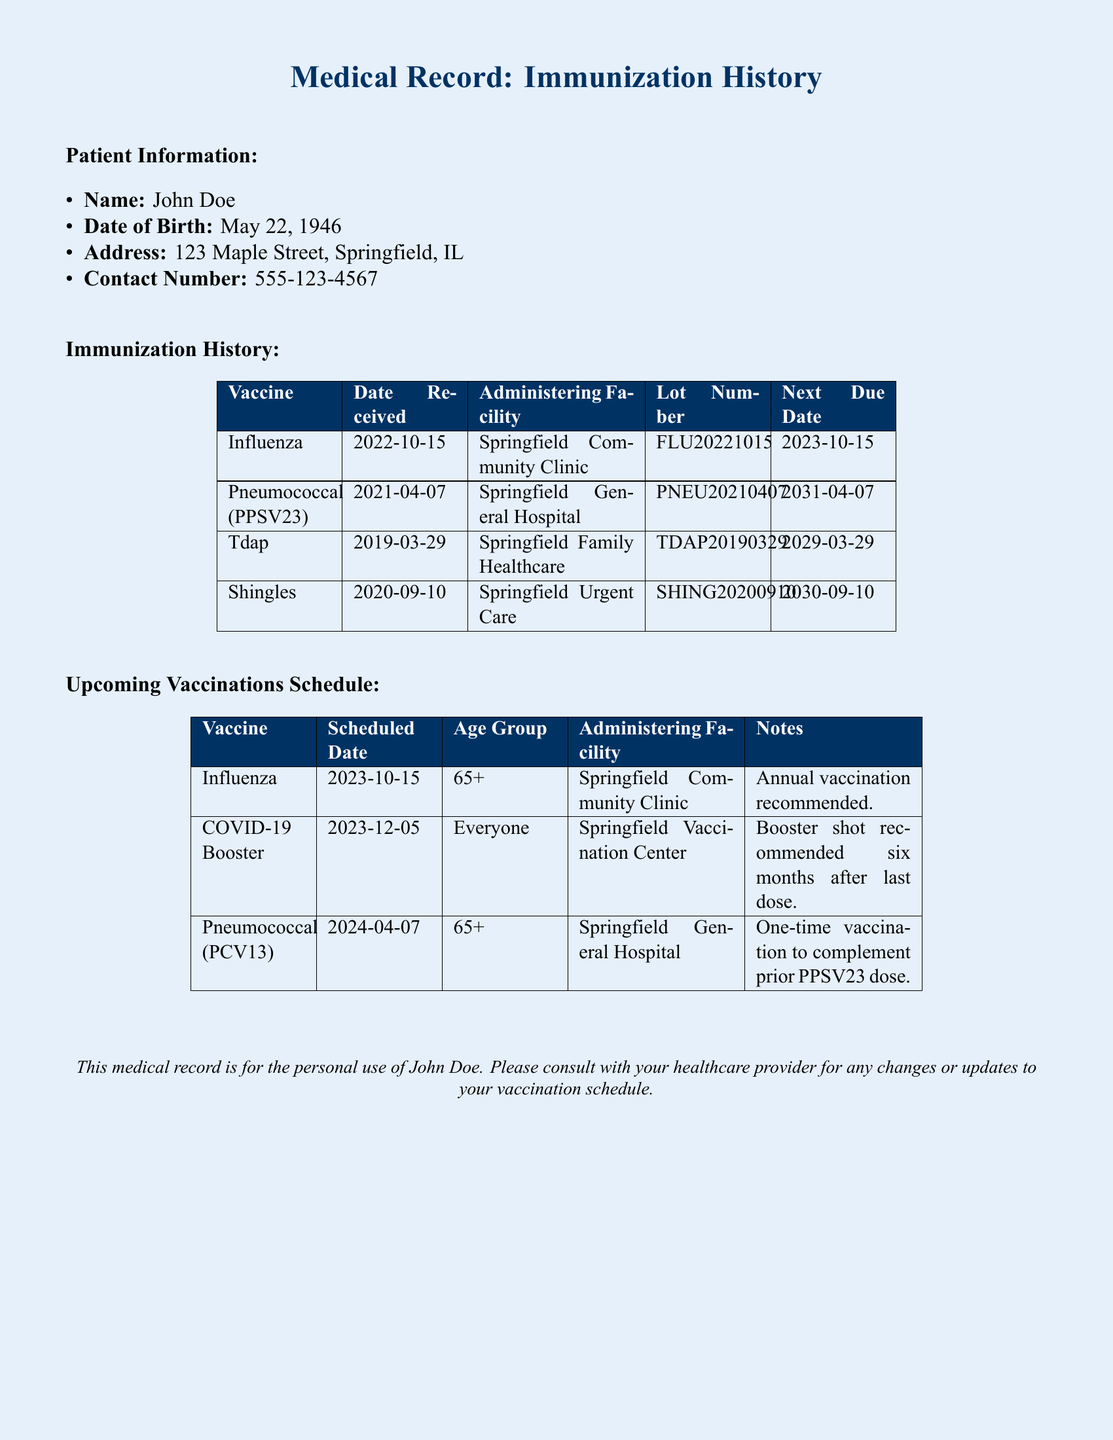What is the name of the patient? The patient's name is listed at the beginning of the document under Patient Information.
Answer: John Doe When was the last influenza vaccine received? The date for the last influenza vaccine is found in the immunization history section.
Answer: 2022-10-15 What is the administering facility for the Tdap vaccine? The administering facility for Tdap is mentioned in the immunization history section.
Answer: Springfield Family Healthcare What is the next due date for the pneumococcal vaccine? The next due date can be found in the immunization history table under the pneumococcal vaccine entry.
Answer: 2031-04-07 How many upcoming vaccinations are scheduled for the patient? By counting the entries in the upcoming vaccinations schedule, we can identify the total.
Answer: 3 What age group is recommended for the influenza vaccine? This information is provided in the upcoming vaccinations schedule under the influenza vaccine.
Answer: 65+ What is the scheduled date for the COVID-19 booster? The date for the COVID-19 booster is specified in the upcoming vaccinations section.
Answer: 2023-12-05 Which vaccine is a one-time vaccination complementary to PPSV23? This information relates to the pneumococcal vaccine in the upcoming vaccinations schedule.
Answer: Pneumococcal (PCV13) What is the color scheme used in the document? The document uses light blue for the background and dark blue for headings and tables.
Answer: Light blue and dark blue 